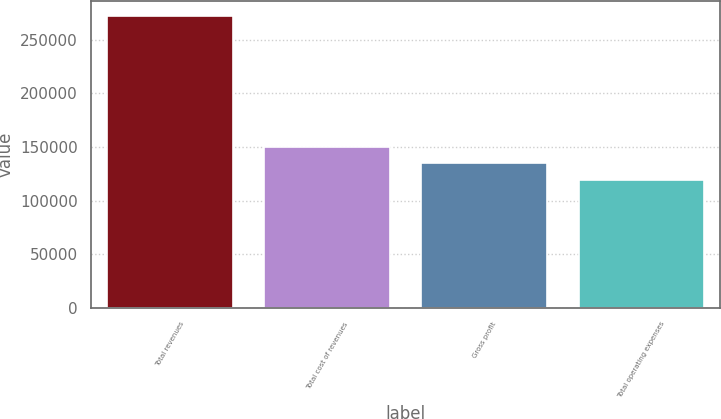Convert chart to OTSL. <chart><loc_0><loc_0><loc_500><loc_500><bar_chart><fcel>Total revenues<fcel>Total cost of revenues<fcel>Gross profit<fcel>Total operating expenses<nl><fcel>272243<fcel>149977<fcel>134694<fcel>119411<nl></chart> 